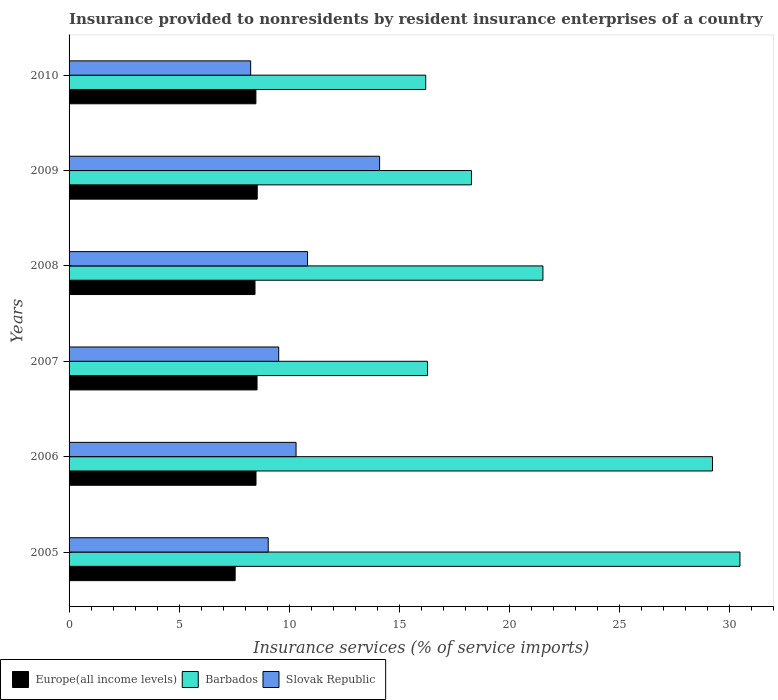How many different coloured bars are there?
Give a very brief answer. 3. How many groups of bars are there?
Your response must be concise. 6. Are the number of bars on each tick of the Y-axis equal?
Your answer should be compact. Yes. How many bars are there on the 1st tick from the top?
Your response must be concise. 3. How many bars are there on the 2nd tick from the bottom?
Provide a succinct answer. 3. What is the label of the 2nd group of bars from the top?
Make the answer very short. 2009. What is the insurance provided to nonresidents in Barbados in 2007?
Make the answer very short. 16.3. Across all years, what is the maximum insurance provided to nonresidents in Slovak Republic?
Offer a very short reply. 14.12. Across all years, what is the minimum insurance provided to nonresidents in Barbados?
Your response must be concise. 16.21. In which year was the insurance provided to nonresidents in Slovak Republic maximum?
Your answer should be very brief. 2009. What is the total insurance provided to nonresidents in Barbados in the graph?
Your response must be concise. 132.09. What is the difference between the insurance provided to nonresidents in Europe(all income levels) in 2006 and that in 2007?
Give a very brief answer. -0.05. What is the difference between the insurance provided to nonresidents in Slovak Republic in 2005 and the insurance provided to nonresidents in Barbados in 2008?
Offer a very short reply. -12.49. What is the average insurance provided to nonresidents in Slovak Republic per year?
Your response must be concise. 10.35. In the year 2007, what is the difference between the insurance provided to nonresidents in Barbados and insurance provided to nonresidents in Slovak Republic?
Your response must be concise. 6.77. What is the ratio of the insurance provided to nonresidents in Europe(all income levels) in 2006 to that in 2008?
Your response must be concise. 1.01. What is the difference between the highest and the second highest insurance provided to nonresidents in Europe(all income levels)?
Your response must be concise. 0.01. What is the difference between the highest and the lowest insurance provided to nonresidents in Europe(all income levels)?
Your response must be concise. 1. Is the sum of the insurance provided to nonresidents in Slovak Republic in 2005 and 2008 greater than the maximum insurance provided to nonresidents in Barbados across all years?
Your response must be concise. No. What does the 3rd bar from the top in 2008 represents?
Provide a short and direct response. Europe(all income levels). What does the 1st bar from the bottom in 2010 represents?
Your answer should be compact. Europe(all income levels). Is it the case that in every year, the sum of the insurance provided to nonresidents in Europe(all income levels) and insurance provided to nonresidents in Barbados is greater than the insurance provided to nonresidents in Slovak Republic?
Make the answer very short. Yes. How many bars are there?
Offer a very short reply. 18. Does the graph contain grids?
Offer a very short reply. No. Where does the legend appear in the graph?
Your answer should be very brief. Bottom left. How are the legend labels stacked?
Your answer should be very brief. Horizontal. What is the title of the graph?
Provide a short and direct response. Insurance provided to nonresidents by resident insurance enterprises of a country. Does "Philippines" appear as one of the legend labels in the graph?
Provide a succinct answer. No. What is the label or title of the X-axis?
Keep it short and to the point. Insurance services (% of service imports). What is the label or title of the Y-axis?
Your response must be concise. Years. What is the Insurance services (% of service imports) of Europe(all income levels) in 2005?
Offer a terse response. 7.55. What is the Insurance services (% of service imports) in Barbados in 2005?
Offer a terse response. 30.5. What is the Insurance services (% of service imports) in Slovak Republic in 2005?
Give a very brief answer. 9.05. What is the Insurance services (% of service imports) in Europe(all income levels) in 2006?
Ensure brevity in your answer.  8.5. What is the Insurance services (% of service imports) of Barbados in 2006?
Provide a succinct answer. 29.25. What is the Insurance services (% of service imports) in Slovak Republic in 2006?
Offer a very short reply. 10.32. What is the Insurance services (% of service imports) of Europe(all income levels) in 2007?
Ensure brevity in your answer.  8.55. What is the Insurance services (% of service imports) in Barbados in 2007?
Your response must be concise. 16.3. What is the Insurance services (% of service imports) of Slovak Republic in 2007?
Keep it short and to the point. 9.53. What is the Insurance services (% of service imports) of Europe(all income levels) in 2008?
Provide a succinct answer. 8.45. What is the Insurance services (% of service imports) of Barbados in 2008?
Your response must be concise. 21.54. What is the Insurance services (% of service imports) of Slovak Republic in 2008?
Your answer should be compact. 10.84. What is the Insurance services (% of service imports) of Europe(all income levels) in 2009?
Your response must be concise. 8.55. What is the Insurance services (% of service imports) of Barbados in 2009?
Give a very brief answer. 18.29. What is the Insurance services (% of service imports) of Slovak Republic in 2009?
Provide a short and direct response. 14.12. What is the Insurance services (% of service imports) of Europe(all income levels) in 2010?
Your answer should be very brief. 8.49. What is the Insurance services (% of service imports) of Barbados in 2010?
Your answer should be compact. 16.21. What is the Insurance services (% of service imports) in Slovak Republic in 2010?
Your answer should be very brief. 8.26. Across all years, what is the maximum Insurance services (% of service imports) of Europe(all income levels)?
Ensure brevity in your answer.  8.55. Across all years, what is the maximum Insurance services (% of service imports) in Barbados?
Your response must be concise. 30.5. Across all years, what is the maximum Insurance services (% of service imports) in Slovak Republic?
Provide a short and direct response. 14.12. Across all years, what is the minimum Insurance services (% of service imports) of Europe(all income levels)?
Make the answer very short. 7.55. Across all years, what is the minimum Insurance services (% of service imports) in Barbados?
Your answer should be very brief. 16.21. Across all years, what is the minimum Insurance services (% of service imports) in Slovak Republic?
Keep it short and to the point. 8.26. What is the total Insurance services (% of service imports) of Europe(all income levels) in the graph?
Your answer should be very brief. 50.09. What is the total Insurance services (% of service imports) of Barbados in the graph?
Offer a terse response. 132.09. What is the total Insurance services (% of service imports) in Slovak Republic in the graph?
Offer a very short reply. 62.11. What is the difference between the Insurance services (% of service imports) of Europe(all income levels) in 2005 and that in 2006?
Keep it short and to the point. -0.95. What is the difference between the Insurance services (% of service imports) of Barbados in 2005 and that in 2006?
Keep it short and to the point. 1.25. What is the difference between the Insurance services (% of service imports) in Slovak Republic in 2005 and that in 2006?
Ensure brevity in your answer.  -1.27. What is the difference between the Insurance services (% of service imports) in Europe(all income levels) in 2005 and that in 2007?
Provide a short and direct response. -1. What is the difference between the Insurance services (% of service imports) of Barbados in 2005 and that in 2007?
Offer a very short reply. 14.2. What is the difference between the Insurance services (% of service imports) of Slovak Republic in 2005 and that in 2007?
Give a very brief answer. -0.48. What is the difference between the Insurance services (% of service imports) of Europe(all income levels) in 2005 and that in 2008?
Offer a terse response. -0.9. What is the difference between the Insurance services (% of service imports) in Barbados in 2005 and that in 2008?
Provide a succinct answer. 8.96. What is the difference between the Insurance services (% of service imports) of Slovak Republic in 2005 and that in 2008?
Give a very brief answer. -1.79. What is the difference between the Insurance services (% of service imports) of Europe(all income levels) in 2005 and that in 2009?
Offer a very short reply. -1. What is the difference between the Insurance services (% of service imports) of Barbados in 2005 and that in 2009?
Your answer should be compact. 12.21. What is the difference between the Insurance services (% of service imports) of Slovak Republic in 2005 and that in 2009?
Give a very brief answer. -5.06. What is the difference between the Insurance services (% of service imports) of Europe(all income levels) in 2005 and that in 2010?
Your response must be concise. -0.94. What is the difference between the Insurance services (% of service imports) in Barbados in 2005 and that in 2010?
Your answer should be compact. 14.28. What is the difference between the Insurance services (% of service imports) in Slovak Republic in 2005 and that in 2010?
Make the answer very short. 0.8. What is the difference between the Insurance services (% of service imports) in Europe(all income levels) in 2006 and that in 2007?
Your answer should be compact. -0.05. What is the difference between the Insurance services (% of service imports) in Barbados in 2006 and that in 2007?
Ensure brevity in your answer.  12.95. What is the difference between the Insurance services (% of service imports) of Slovak Republic in 2006 and that in 2007?
Keep it short and to the point. 0.79. What is the difference between the Insurance services (% of service imports) in Europe(all income levels) in 2006 and that in 2008?
Keep it short and to the point. 0.05. What is the difference between the Insurance services (% of service imports) of Barbados in 2006 and that in 2008?
Ensure brevity in your answer.  7.71. What is the difference between the Insurance services (% of service imports) of Slovak Republic in 2006 and that in 2008?
Provide a succinct answer. -0.52. What is the difference between the Insurance services (% of service imports) of Europe(all income levels) in 2006 and that in 2009?
Your answer should be compact. -0.06. What is the difference between the Insurance services (% of service imports) in Barbados in 2006 and that in 2009?
Your answer should be very brief. 10.96. What is the difference between the Insurance services (% of service imports) in Slovak Republic in 2006 and that in 2009?
Provide a short and direct response. -3.8. What is the difference between the Insurance services (% of service imports) of Europe(all income levels) in 2006 and that in 2010?
Make the answer very short. 0.01. What is the difference between the Insurance services (% of service imports) of Barbados in 2006 and that in 2010?
Offer a terse response. 13.04. What is the difference between the Insurance services (% of service imports) in Slovak Republic in 2006 and that in 2010?
Offer a very short reply. 2.06. What is the difference between the Insurance services (% of service imports) in Europe(all income levels) in 2007 and that in 2008?
Make the answer very short. 0.09. What is the difference between the Insurance services (% of service imports) of Barbados in 2007 and that in 2008?
Your answer should be very brief. -5.24. What is the difference between the Insurance services (% of service imports) of Slovak Republic in 2007 and that in 2008?
Your answer should be very brief. -1.31. What is the difference between the Insurance services (% of service imports) of Europe(all income levels) in 2007 and that in 2009?
Provide a succinct answer. -0.01. What is the difference between the Insurance services (% of service imports) of Barbados in 2007 and that in 2009?
Keep it short and to the point. -2. What is the difference between the Insurance services (% of service imports) of Slovak Republic in 2007 and that in 2009?
Provide a short and direct response. -4.59. What is the difference between the Insurance services (% of service imports) in Europe(all income levels) in 2007 and that in 2010?
Provide a succinct answer. 0.05. What is the difference between the Insurance services (% of service imports) in Barbados in 2007 and that in 2010?
Keep it short and to the point. 0.08. What is the difference between the Insurance services (% of service imports) of Slovak Republic in 2007 and that in 2010?
Your response must be concise. 1.27. What is the difference between the Insurance services (% of service imports) of Europe(all income levels) in 2008 and that in 2009?
Offer a very short reply. -0.1. What is the difference between the Insurance services (% of service imports) of Barbados in 2008 and that in 2009?
Keep it short and to the point. 3.25. What is the difference between the Insurance services (% of service imports) of Slovak Republic in 2008 and that in 2009?
Provide a succinct answer. -3.28. What is the difference between the Insurance services (% of service imports) in Europe(all income levels) in 2008 and that in 2010?
Provide a short and direct response. -0.04. What is the difference between the Insurance services (% of service imports) of Barbados in 2008 and that in 2010?
Make the answer very short. 5.33. What is the difference between the Insurance services (% of service imports) of Slovak Republic in 2008 and that in 2010?
Ensure brevity in your answer.  2.58. What is the difference between the Insurance services (% of service imports) in Europe(all income levels) in 2009 and that in 2010?
Keep it short and to the point. 0.06. What is the difference between the Insurance services (% of service imports) in Barbados in 2009 and that in 2010?
Give a very brief answer. 2.08. What is the difference between the Insurance services (% of service imports) of Slovak Republic in 2009 and that in 2010?
Your answer should be compact. 5.86. What is the difference between the Insurance services (% of service imports) in Europe(all income levels) in 2005 and the Insurance services (% of service imports) in Barbados in 2006?
Your response must be concise. -21.7. What is the difference between the Insurance services (% of service imports) in Europe(all income levels) in 2005 and the Insurance services (% of service imports) in Slovak Republic in 2006?
Make the answer very short. -2.77. What is the difference between the Insurance services (% of service imports) of Barbados in 2005 and the Insurance services (% of service imports) of Slovak Republic in 2006?
Your response must be concise. 20.18. What is the difference between the Insurance services (% of service imports) of Europe(all income levels) in 2005 and the Insurance services (% of service imports) of Barbados in 2007?
Your answer should be compact. -8.75. What is the difference between the Insurance services (% of service imports) of Europe(all income levels) in 2005 and the Insurance services (% of service imports) of Slovak Republic in 2007?
Your answer should be very brief. -1.98. What is the difference between the Insurance services (% of service imports) of Barbados in 2005 and the Insurance services (% of service imports) of Slovak Republic in 2007?
Provide a succinct answer. 20.97. What is the difference between the Insurance services (% of service imports) in Europe(all income levels) in 2005 and the Insurance services (% of service imports) in Barbados in 2008?
Offer a very short reply. -13.99. What is the difference between the Insurance services (% of service imports) of Europe(all income levels) in 2005 and the Insurance services (% of service imports) of Slovak Republic in 2008?
Provide a succinct answer. -3.29. What is the difference between the Insurance services (% of service imports) in Barbados in 2005 and the Insurance services (% of service imports) in Slovak Republic in 2008?
Offer a very short reply. 19.66. What is the difference between the Insurance services (% of service imports) in Europe(all income levels) in 2005 and the Insurance services (% of service imports) in Barbados in 2009?
Offer a terse response. -10.74. What is the difference between the Insurance services (% of service imports) of Europe(all income levels) in 2005 and the Insurance services (% of service imports) of Slovak Republic in 2009?
Give a very brief answer. -6.57. What is the difference between the Insurance services (% of service imports) of Barbados in 2005 and the Insurance services (% of service imports) of Slovak Republic in 2009?
Keep it short and to the point. 16.38. What is the difference between the Insurance services (% of service imports) in Europe(all income levels) in 2005 and the Insurance services (% of service imports) in Barbados in 2010?
Your answer should be compact. -8.66. What is the difference between the Insurance services (% of service imports) in Europe(all income levels) in 2005 and the Insurance services (% of service imports) in Slovak Republic in 2010?
Your answer should be very brief. -0.71. What is the difference between the Insurance services (% of service imports) in Barbados in 2005 and the Insurance services (% of service imports) in Slovak Republic in 2010?
Offer a terse response. 22.24. What is the difference between the Insurance services (% of service imports) of Europe(all income levels) in 2006 and the Insurance services (% of service imports) of Barbados in 2007?
Offer a terse response. -7.8. What is the difference between the Insurance services (% of service imports) of Europe(all income levels) in 2006 and the Insurance services (% of service imports) of Slovak Republic in 2007?
Your answer should be compact. -1.03. What is the difference between the Insurance services (% of service imports) in Barbados in 2006 and the Insurance services (% of service imports) in Slovak Republic in 2007?
Provide a short and direct response. 19.72. What is the difference between the Insurance services (% of service imports) of Europe(all income levels) in 2006 and the Insurance services (% of service imports) of Barbados in 2008?
Provide a short and direct response. -13.04. What is the difference between the Insurance services (% of service imports) in Europe(all income levels) in 2006 and the Insurance services (% of service imports) in Slovak Republic in 2008?
Keep it short and to the point. -2.34. What is the difference between the Insurance services (% of service imports) in Barbados in 2006 and the Insurance services (% of service imports) in Slovak Republic in 2008?
Provide a short and direct response. 18.41. What is the difference between the Insurance services (% of service imports) in Europe(all income levels) in 2006 and the Insurance services (% of service imports) in Barbados in 2009?
Your answer should be very brief. -9.79. What is the difference between the Insurance services (% of service imports) in Europe(all income levels) in 2006 and the Insurance services (% of service imports) in Slovak Republic in 2009?
Your answer should be very brief. -5.62. What is the difference between the Insurance services (% of service imports) of Barbados in 2006 and the Insurance services (% of service imports) of Slovak Republic in 2009?
Keep it short and to the point. 15.13. What is the difference between the Insurance services (% of service imports) in Europe(all income levels) in 2006 and the Insurance services (% of service imports) in Barbados in 2010?
Your response must be concise. -7.72. What is the difference between the Insurance services (% of service imports) of Europe(all income levels) in 2006 and the Insurance services (% of service imports) of Slovak Republic in 2010?
Offer a terse response. 0.24. What is the difference between the Insurance services (% of service imports) in Barbados in 2006 and the Insurance services (% of service imports) in Slovak Republic in 2010?
Offer a terse response. 20.99. What is the difference between the Insurance services (% of service imports) of Europe(all income levels) in 2007 and the Insurance services (% of service imports) of Barbados in 2008?
Your answer should be very brief. -13. What is the difference between the Insurance services (% of service imports) of Europe(all income levels) in 2007 and the Insurance services (% of service imports) of Slovak Republic in 2008?
Offer a very short reply. -2.29. What is the difference between the Insurance services (% of service imports) in Barbados in 2007 and the Insurance services (% of service imports) in Slovak Republic in 2008?
Provide a short and direct response. 5.46. What is the difference between the Insurance services (% of service imports) of Europe(all income levels) in 2007 and the Insurance services (% of service imports) of Barbados in 2009?
Give a very brief answer. -9.75. What is the difference between the Insurance services (% of service imports) of Europe(all income levels) in 2007 and the Insurance services (% of service imports) of Slovak Republic in 2009?
Your response must be concise. -5.57. What is the difference between the Insurance services (% of service imports) of Barbados in 2007 and the Insurance services (% of service imports) of Slovak Republic in 2009?
Keep it short and to the point. 2.18. What is the difference between the Insurance services (% of service imports) in Europe(all income levels) in 2007 and the Insurance services (% of service imports) in Barbados in 2010?
Provide a short and direct response. -7.67. What is the difference between the Insurance services (% of service imports) in Europe(all income levels) in 2007 and the Insurance services (% of service imports) in Slovak Republic in 2010?
Make the answer very short. 0.29. What is the difference between the Insurance services (% of service imports) in Barbados in 2007 and the Insurance services (% of service imports) in Slovak Republic in 2010?
Your answer should be compact. 8.04. What is the difference between the Insurance services (% of service imports) in Europe(all income levels) in 2008 and the Insurance services (% of service imports) in Barbados in 2009?
Offer a terse response. -9.84. What is the difference between the Insurance services (% of service imports) of Europe(all income levels) in 2008 and the Insurance services (% of service imports) of Slovak Republic in 2009?
Your response must be concise. -5.66. What is the difference between the Insurance services (% of service imports) of Barbados in 2008 and the Insurance services (% of service imports) of Slovak Republic in 2009?
Provide a short and direct response. 7.42. What is the difference between the Insurance services (% of service imports) of Europe(all income levels) in 2008 and the Insurance services (% of service imports) of Barbados in 2010?
Offer a very short reply. -7.76. What is the difference between the Insurance services (% of service imports) in Europe(all income levels) in 2008 and the Insurance services (% of service imports) in Slovak Republic in 2010?
Your response must be concise. 0.2. What is the difference between the Insurance services (% of service imports) of Barbados in 2008 and the Insurance services (% of service imports) of Slovak Republic in 2010?
Give a very brief answer. 13.29. What is the difference between the Insurance services (% of service imports) in Europe(all income levels) in 2009 and the Insurance services (% of service imports) in Barbados in 2010?
Your answer should be very brief. -7.66. What is the difference between the Insurance services (% of service imports) in Europe(all income levels) in 2009 and the Insurance services (% of service imports) in Slovak Republic in 2010?
Provide a short and direct response. 0.3. What is the difference between the Insurance services (% of service imports) in Barbados in 2009 and the Insurance services (% of service imports) in Slovak Republic in 2010?
Provide a short and direct response. 10.04. What is the average Insurance services (% of service imports) in Europe(all income levels) per year?
Make the answer very short. 8.35. What is the average Insurance services (% of service imports) of Barbados per year?
Provide a short and direct response. 22.01. What is the average Insurance services (% of service imports) of Slovak Republic per year?
Offer a very short reply. 10.35. In the year 2005, what is the difference between the Insurance services (% of service imports) in Europe(all income levels) and Insurance services (% of service imports) in Barbados?
Ensure brevity in your answer.  -22.95. In the year 2005, what is the difference between the Insurance services (% of service imports) in Europe(all income levels) and Insurance services (% of service imports) in Slovak Republic?
Make the answer very short. -1.5. In the year 2005, what is the difference between the Insurance services (% of service imports) of Barbados and Insurance services (% of service imports) of Slovak Republic?
Your response must be concise. 21.44. In the year 2006, what is the difference between the Insurance services (% of service imports) of Europe(all income levels) and Insurance services (% of service imports) of Barbados?
Your answer should be very brief. -20.75. In the year 2006, what is the difference between the Insurance services (% of service imports) in Europe(all income levels) and Insurance services (% of service imports) in Slovak Republic?
Give a very brief answer. -1.82. In the year 2006, what is the difference between the Insurance services (% of service imports) of Barbados and Insurance services (% of service imports) of Slovak Republic?
Keep it short and to the point. 18.93. In the year 2007, what is the difference between the Insurance services (% of service imports) of Europe(all income levels) and Insurance services (% of service imports) of Barbados?
Ensure brevity in your answer.  -7.75. In the year 2007, what is the difference between the Insurance services (% of service imports) of Europe(all income levels) and Insurance services (% of service imports) of Slovak Republic?
Ensure brevity in your answer.  -0.98. In the year 2007, what is the difference between the Insurance services (% of service imports) in Barbados and Insurance services (% of service imports) in Slovak Republic?
Your response must be concise. 6.77. In the year 2008, what is the difference between the Insurance services (% of service imports) of Europe(all income levels) and Insurance services (% of service imports) of Barbados?
Your answer should be very brief. -13.09. In the year 2008, what is the difference between the Insurance services (% of service imports) of Europe(all income levels) and Insurance services (% of service imports) of Slovak Republic?
Your response must be concise. -2.39. In the year 2008, what is the difference between the Insurance services (% of service imports) of Barbados and Insurance services (% of service imports) of Slovak Republic?
Make the answer very short. 10.7. In the year 2009, what is the difference between the Insurance services (% of service imports) of Europe(all income levels) and Insurance services (% of service imports) of Barbados?
Provide a succinct answer. -9.74. In the year 2009, what is the difference between the Insurance services (% of service imports) in Europe(all income levels) and Insurance services (% of service imports) in Slovak Republic?
Ensure brevity in your answer.  -5.56. In the year 2009, what is the difference between the Insurance services (% of service imports) of Barbados and Insurance services (% of service imports) of Slovak Republic?
Make the answer very short. 4.18. In the year 2010, what is the difference between the Insurance services (% of service imports) in Europe(all income levels) and Insurance services (% of service imports) in Barbados?
Provide a short and direct response. -7.72. In the year 2010, what is the difference between the Insurance services (% of service imports) of Europe(all income levels) and Insurance services (% of service imports) of Slovak Republic?
Your response must be concise. 0.24. In the year 2010, what is the difference between the Insurance services (% of service imports) in Barbados and Insurance services (% of service imports) in Slovak Republic?
Your answer should be compact. 7.96. What is the ratio of the Insurance services (% of service imports) of Europe(all income levels) in 2005 to that in 2006?
Provide a succinct answer. 0.89. What is the ratio of the Insurance services (% of service imports) in Barbados in 2005 to that in 2006?
Your answer should be compact. 1.04. What is the ratio of the Insurance services (% of service imports) in Slovak Republic in 2005 to that in 2006?
Your answer should be very brief. 0.88. What is the ratio of the Insurance services (% of service imports) of Europe(all income levels) in 2005 to that in 2007?
Give a very brief answer. 0.88. What is the ratio of the Insurance services (% of service imports) in Barbados in 2005 to that in 2007?
Ensure brevity in your answer.  1.87. What is the ratio of the Insurance services (% of service imports) in Slovak Republic in 2005 to that in 2007?
Provide a short and direct response. 0.95. What is the ratio of the Insurance services (% of service imports) in Europe(all income levels) in 2005 to that in 2008?
Give a very brief answer. 0.89. What is the ratio of the Insurance services (% of service imports) of Barbados in 2005 to that in 2008?
Your response must be concise. 1.42. What is the ratio of the Insurance services (% of service imports) in Slovak Republic in 2005 to that in 2008?
Give a very brief answer. 0.84. What is the ratio of the Insurance services (% of service imports) in Europe(all income levels) in 2005 to that in 2009?
Ensure brevity in your answer.  0.88. What is the ratio of the Insurance services (% of service imports) of Barbados in 2005 to that in 2009?
Offer a very short reply. 1.67. What is the ratio of the Insurance services (% of service imports) of Slovak Republic in 2005 to that in 2009?
Your response must be concise. 0.64. What is the ratio of the Insurance services (% of service imports) in Europe(all income levels) in 2005 to that in 2010?
Ensure brevity in your answer.  0.89. What is the ratio of the Insurance services (% of service imports) in Barbados in 2005 to that in 2010?
Your response must be concise. 1.88. What is the ratio of the Insurance services (% of service imports) of Slovak Republic in 2005 to that in 2010?
Keep it short and to the point. 1.1. What is the ratio of the Insurance services (% of service imports) in Europe(all income levels) in 2006 to that in 2007?
Your answer should be compact. 0.99. What is the ratio of the Insurance services (% of service imports) of Barbados in 2006 to that in 2007?
Ensure brevity in your answer.  1.79. What is the ratio of the Insurance services (% of service imports) of Slovak Republic in 2006 to that in 2007?
Your answer should be very brief. 1.08. What is the ratio of the Insurance services (% of service imports) in Europe(all income levels) in 2006 to that in 2008?
Your answer should be very brief. 1.01. What is the ratio of the Insurance services (% of service imports) in Barbados in 2006 to that in 2008?
Provide a succinct answer. 1.36. What is the ratio of the Insurance services (% of service imports) in Europe(all income levels) in 2006 to that in 2009?
Offer a terse response. 0.99. What is the ratio of the Insurance services (% of service imports) of Barbados in 2006 to that in 2009?
Your response must be concise. 1.6. What is the ratio of the Insurance services (% of service imports) of Slovak Republic in 2006 to that in 2009?
Keep it short and to the point. 0.73. What is the ratio of the Insurance services (% of service imports) in Europe(all income levels) in 2006 to that in 2010?
Offer a terse response. 1. What is the ratio of the Insurance services (% of service imports) in Barbados in 2006 to that in 2010?
Offer a very short reply. 1.8. What is the ratio of the Insurance services (% of service imports) of Slovak Republic in 2006 to that in 2010?
Give a very brief answer. 1.25. What is the ratio of the Insurance services (% of service imports) in Barbados in 2007 to that in 2008?
Ensure brevity in your answer.  0.76. What is the ratio of the Insurance services (% of service imports) of Slovak Republic in 2007 to that in 2008?
Offer a very short reply. 0.88. What is the ratio of the Insurance services (% of service imports) of Europe(all income levels) in 2007 to that in 2009?
Your answer should be compact. 1. What is the ratio of the Insurance services (% of service imports) of Barbados in 2007 to that in 2009?
Your answer should be very brief. 0.89. What is the ratio of the Insurance services (% of service imports) of Slovak Republic in 2007 to that in 2009?
Keep it short and to the point. 0.68. What is the ratio of the Insurance services (% of service imports) of Slovak Republic in 2007 to that in 2010?
Provide a short and direct response. 1.15. What is the ratio of the Insurance services (% of service imports) in Barbados in 2008 to that in 2009?
Provide a succinct answer. 1.18. What is the ratio of the Insurance services (% of service imports) of Slovak Republic in 2008 to that in 2009?
Give a very brief answer. 0.77. What is the ratio of the Insurance services (% of service imports) in Barbados in 2008 to that in 2010?
Make the answer very short. 1.33. What is the ratio of the Insurance services (% of service imports) in Slovak Republic in 2008 to that in 2010?
Your response must be concise. 1.31. What is the ratio of the Insurance services (% of service imports) in Europe(all income levels) in 2009 to that in 2010?
Offer a very short reply. 1.01. What is the ratio of the Insurance services (% of service imports) of Barbados in 2009 to that in 2010?
Ensure brevity in your answer.  1.13. What is the ratio of the Insurance services (% of service imports) in Slovak Republic in 2009 to that in 2010?
Your answer should be compact. 1.71. What is the difference between the highest and the second highest Insurance services (% of service imports) of Europe(all income levels)?
Provide a short and direct response. 0.01. What is the difference between the highest and the second highest Insurance services (% of service imports) of Barbados?
Give a very brief answer. 1.25. What is the difference between the highest and the second highest Insurance services (% of service imports) in Slovak Republic?
Give a very brief answer. 3.28. What is the difference between the highest and the lowest Insurance services (% of service imports) of Barbados?
Offer a terse response. 14.28. What is the difference between the highest and the lowest Insurance services (% of service imports) of Slovak Republic?
Your response must be concise. 5.86. 